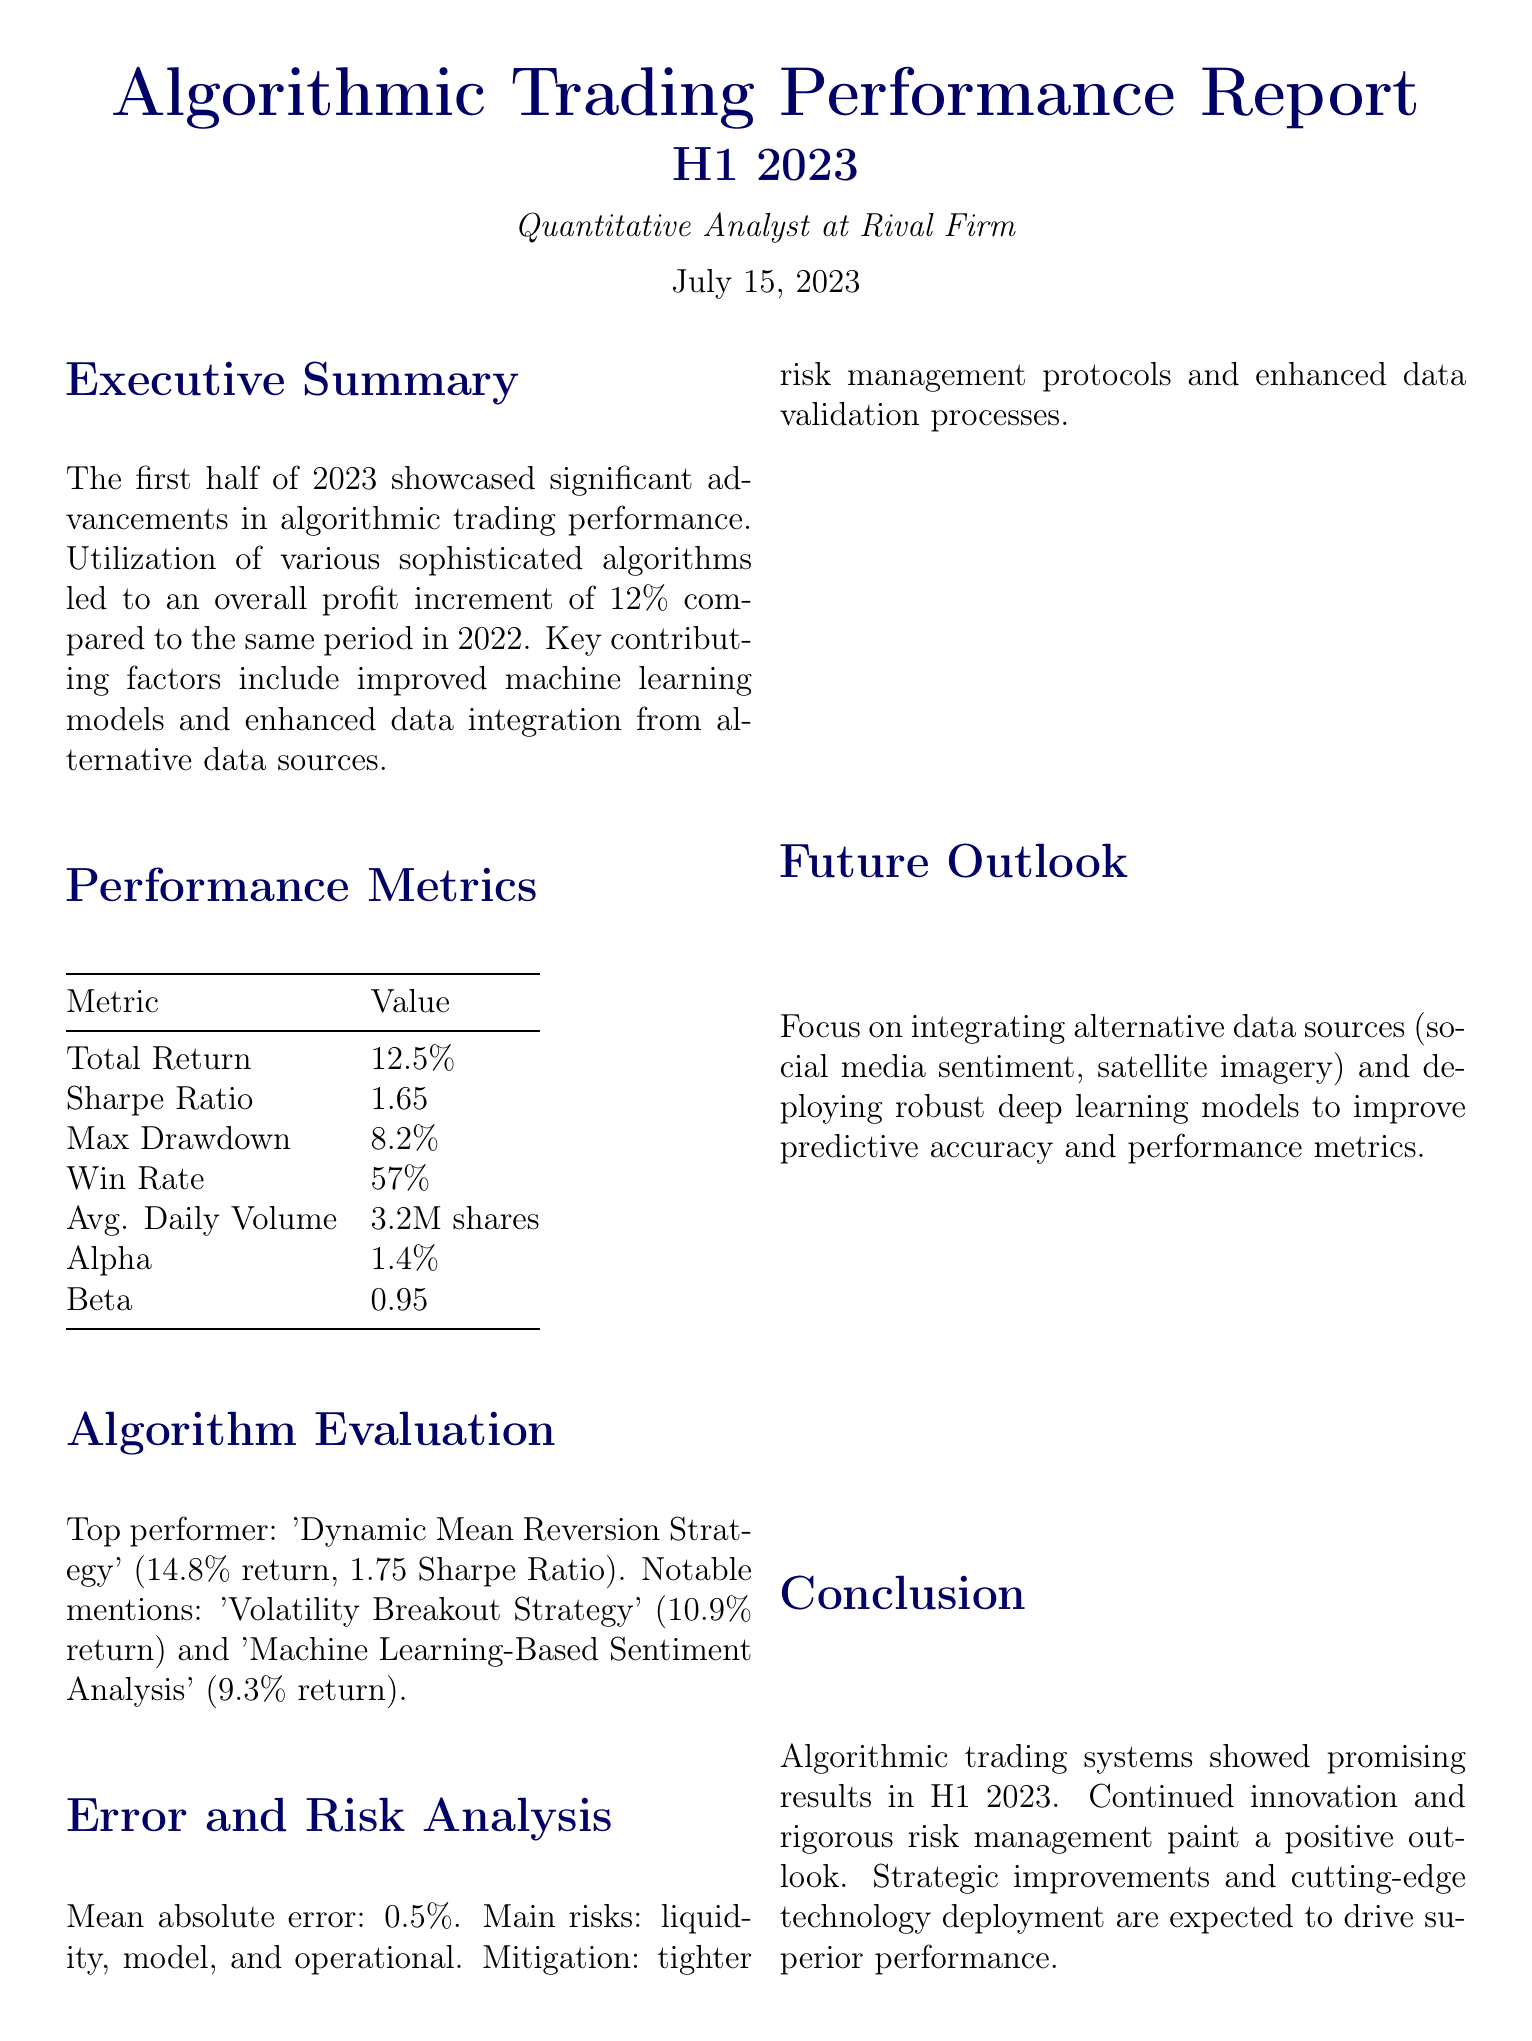What was the overall profit increment compared to H1 2022? The report states a profit increment of 12% compared to the same period in 2022.
Answer: 12% What is the Sharpe Ratio reported in the document? The performance metrics section lists the Sharpe Ratio as 1.65.
Answer: 1.65 What is the return of the top-performing strategy? The 'Dynamic Mean Reversion Strategy' achieved a return of 14.8%.
Answer: 14.8% What was the maximum drawdown recorded? The report specifies a maximum drawdown of 8.2%.
Answer: 8.2% What was the average daily volume in shares? The average daily volume mentioned is 3.2 million shares.
Answer: 3.2M shares Which metric indicates the performance against a market index? The metric for measuring active return against a market index is Alpha.
Answer: Alpha What is the main risk identified in the error analysis? The report identifies liquidity as a main risk.
Answer: liquidity Which strategy had a return of 10.9%? The 'Volatility Breakout Strategy' had a return of 10.9%.
Answer: Volatility Breakout Strategy In what key area does the future outlook focus? The future outlook emphasizes integrating alternative data sources.
Answer: alternative data sources 